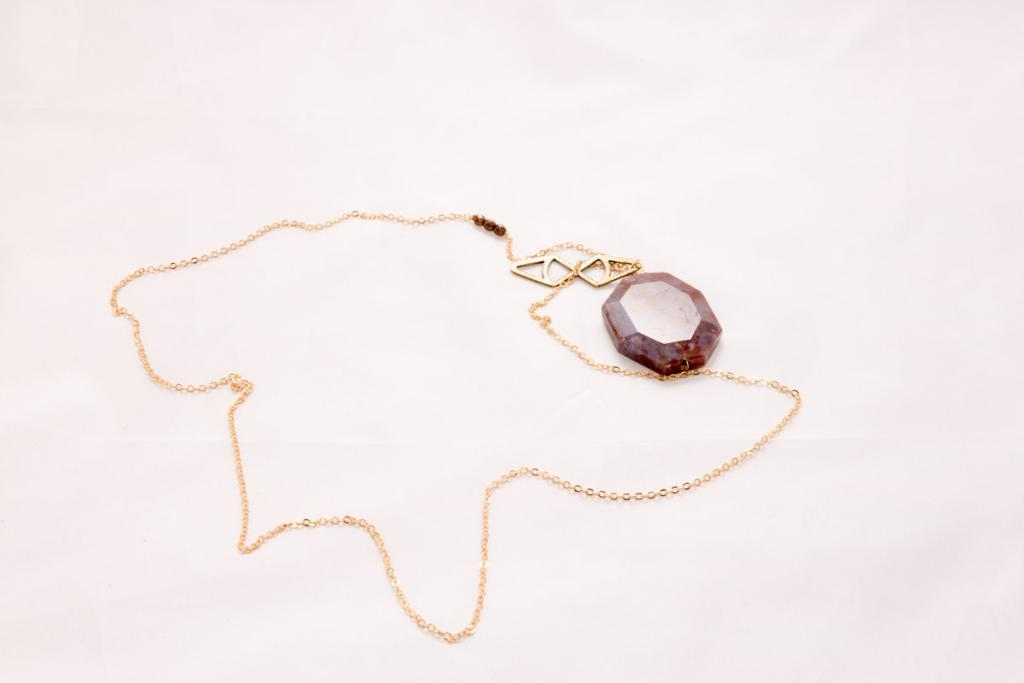What type of jewelry is present in the image? There is a golden color necklace in the image. What is the color of the surface on which the necklace is placed? The necklace is on a white color surface. What type of leather material can be seen in the image? There is no leather material present in the image. Is there any evidence of a battle taking place in the image? There is no indication of a battle in the image; it features a golden color necklace on a white color surface. 